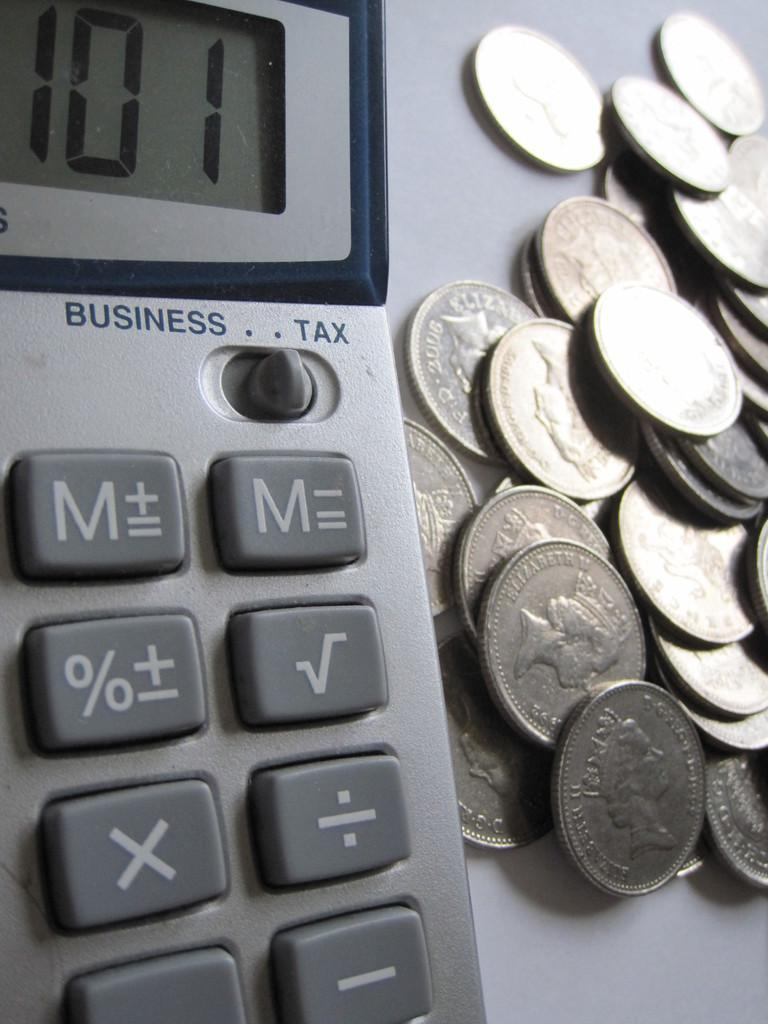<image>
Offer a succinct explanation of the picture presented. A calculator that reads 101 and some quarters lay next to it. 